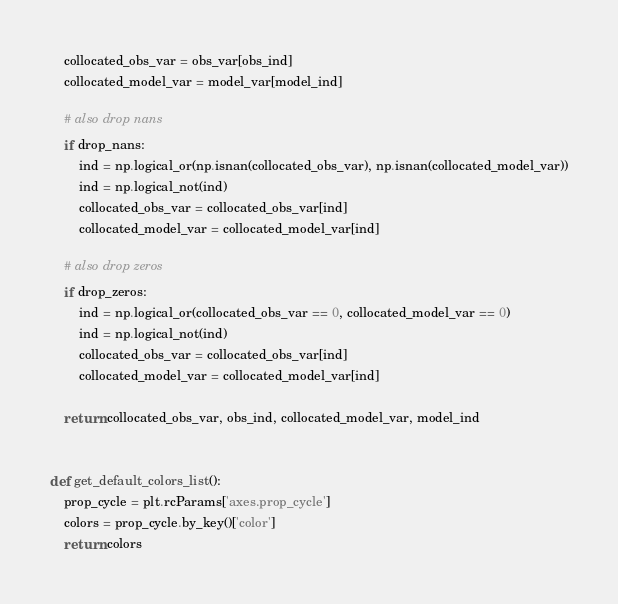<code> <loc_0><loc_0><loc_500><loc_500><_Python_>    collocated_obs_var = obs_var[obs_ind]
    collocated_model_var = model_var[model_ind]

    # also drop nans
    if drop_nans:
        ind = np.logical_or(np.isnan(collocated_obs_var), np.isnan(collocated_model_var))
        ind = np.logical_not(ind)
        collocated_obs_var = collocated_obs_var[ind]
        collocated_model_var = collocated_model_var[ind]

    # also drop zeros
    if drop_zeros:
        ind = np.logical_or(collocated_obs_var == 0, collocated_model_var == 0)
        ind = np.logical_not(ind)
        collocated_obs_var = collocated_obs_var[ind]
        collocated_model_var = collocated_model_var[ind]

    return collocated_obs_var, obs_ind, collocated_model_var, model_ind


def get_default_colors_list():
    prop_cycle = plt.rcParams['axes.prop_cycle']
    colors = prop_cycle.by_key()['color']
    return colors
</code> 